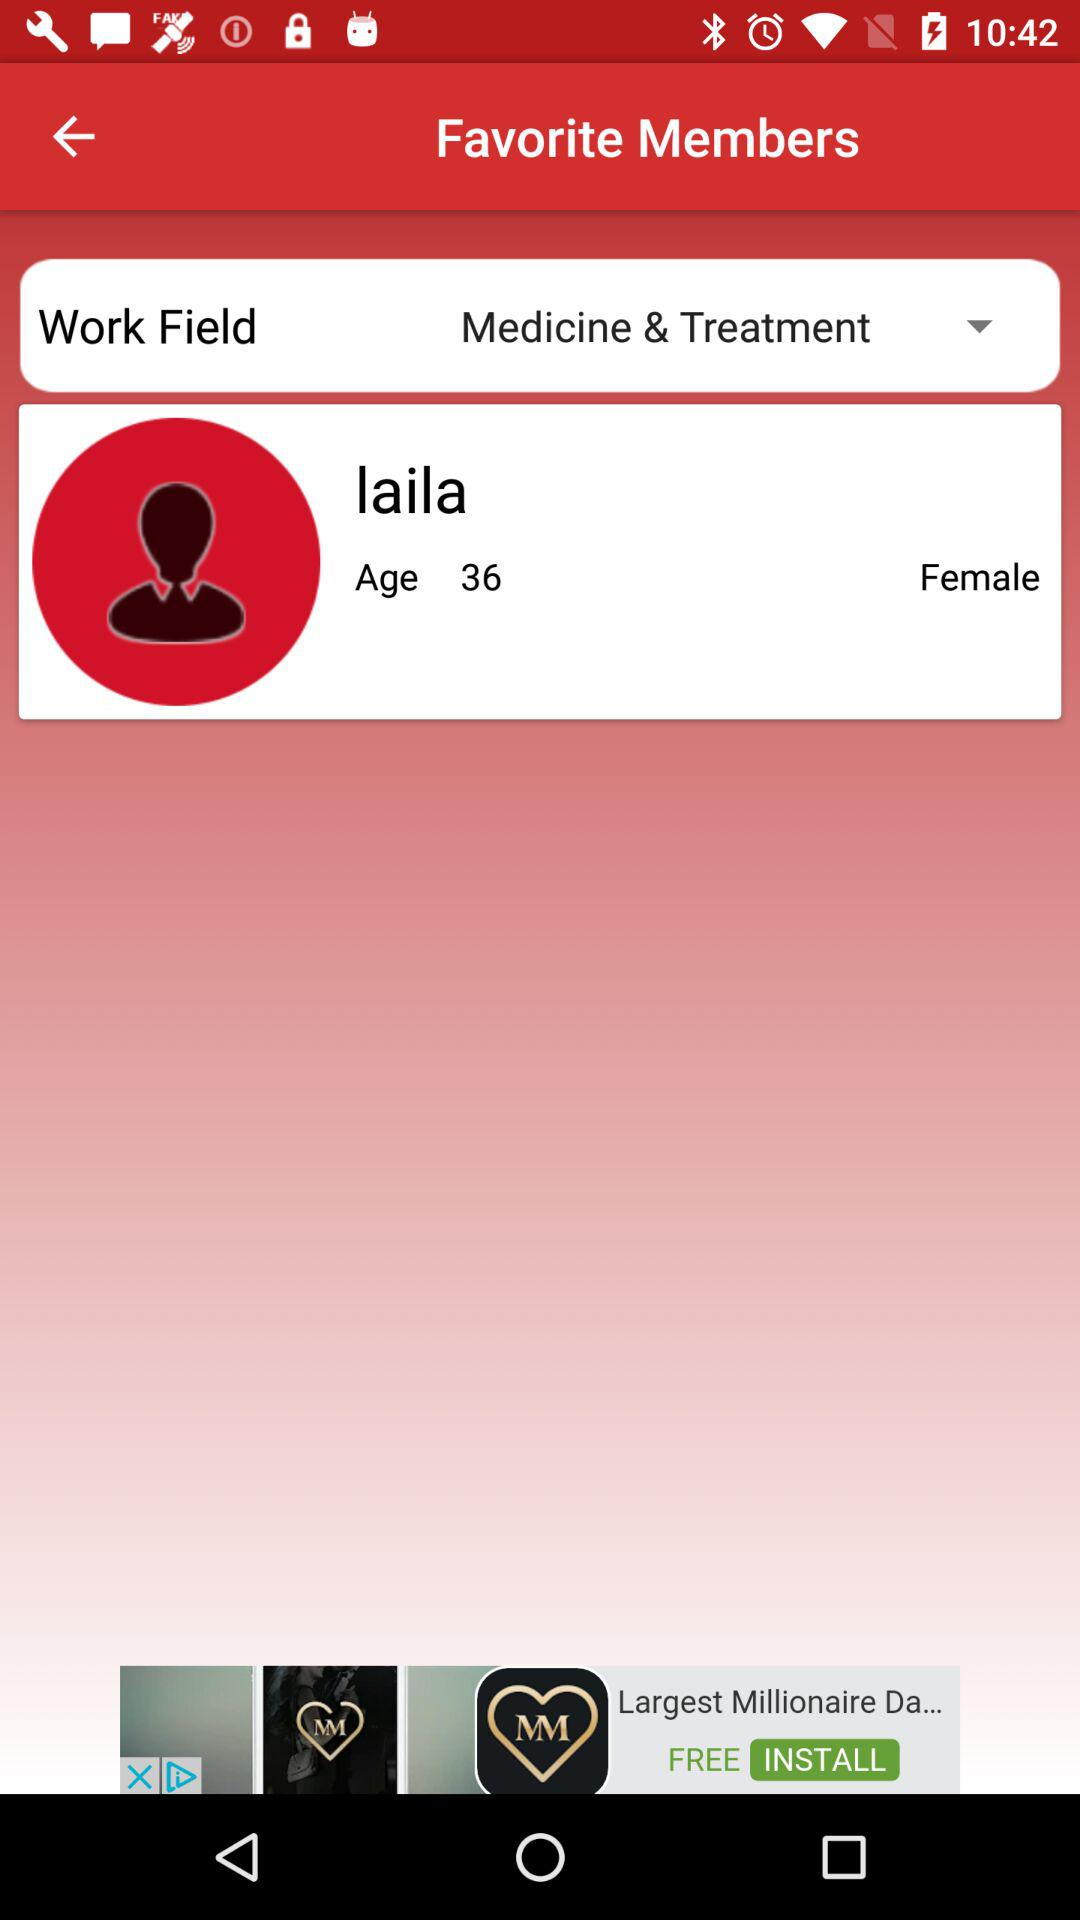How many members are there in the Medicine & Treatment work field?
Answer the question using a single word or phrase. 1 